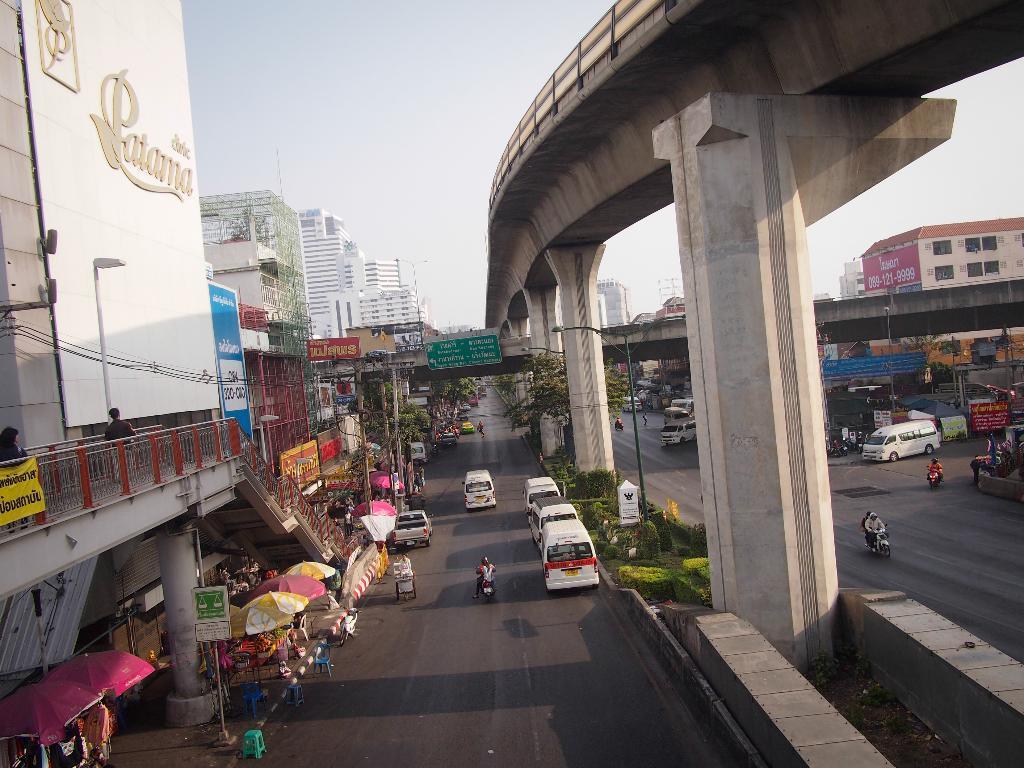Please provide a concise description of this image. In this image, there are a few buildings, poles, umbrellas, vehicles, people, boards with text. We can see the ground. We can see some grass, plants and trees. We can also see the railing and the bridge. We can also see some signboards and the sky. 